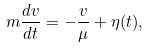Convert formula to latex. <formula><loc_0><loc_0><loc_500><loc_500>m { \frac { d v } { d t } } = - { \frac { v } { \mu } } + { \eta } ( t ) ,</formula> 